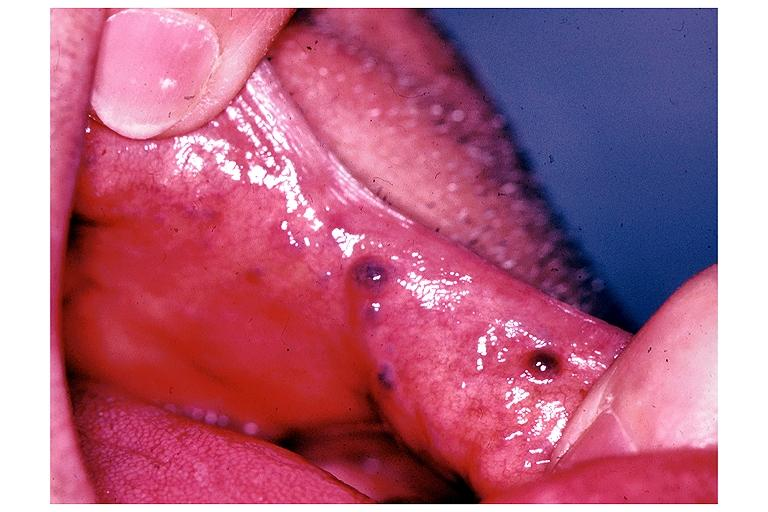does metastatic carcinoma show varix?
Answer the question using a single word or phrase. No 